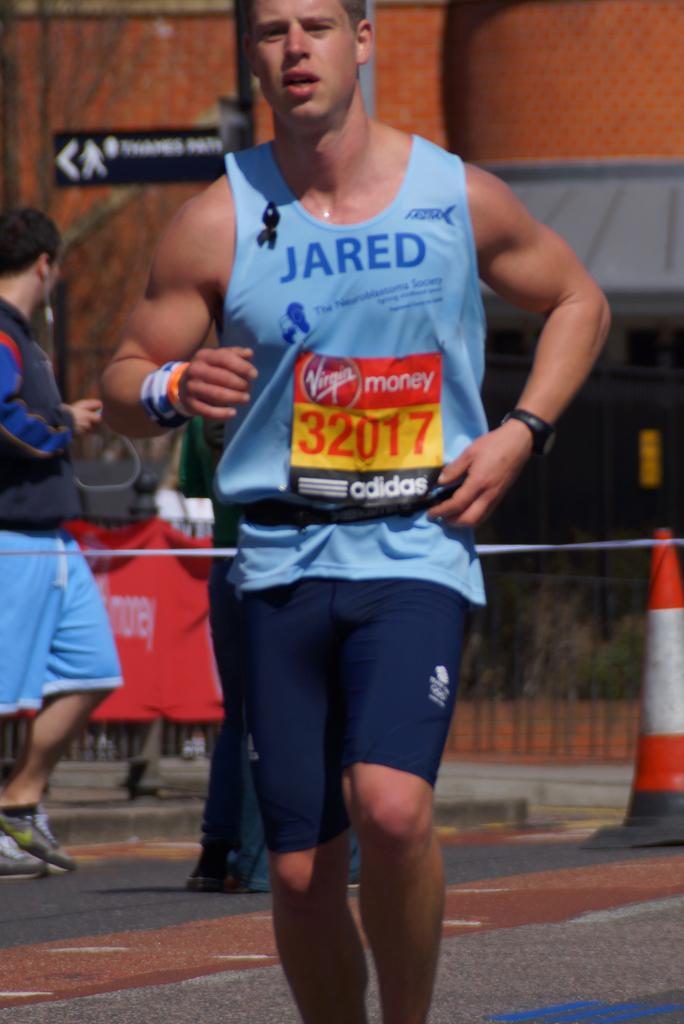What male name is written on the man's shirt?
Offer a very short reply. Jared. 